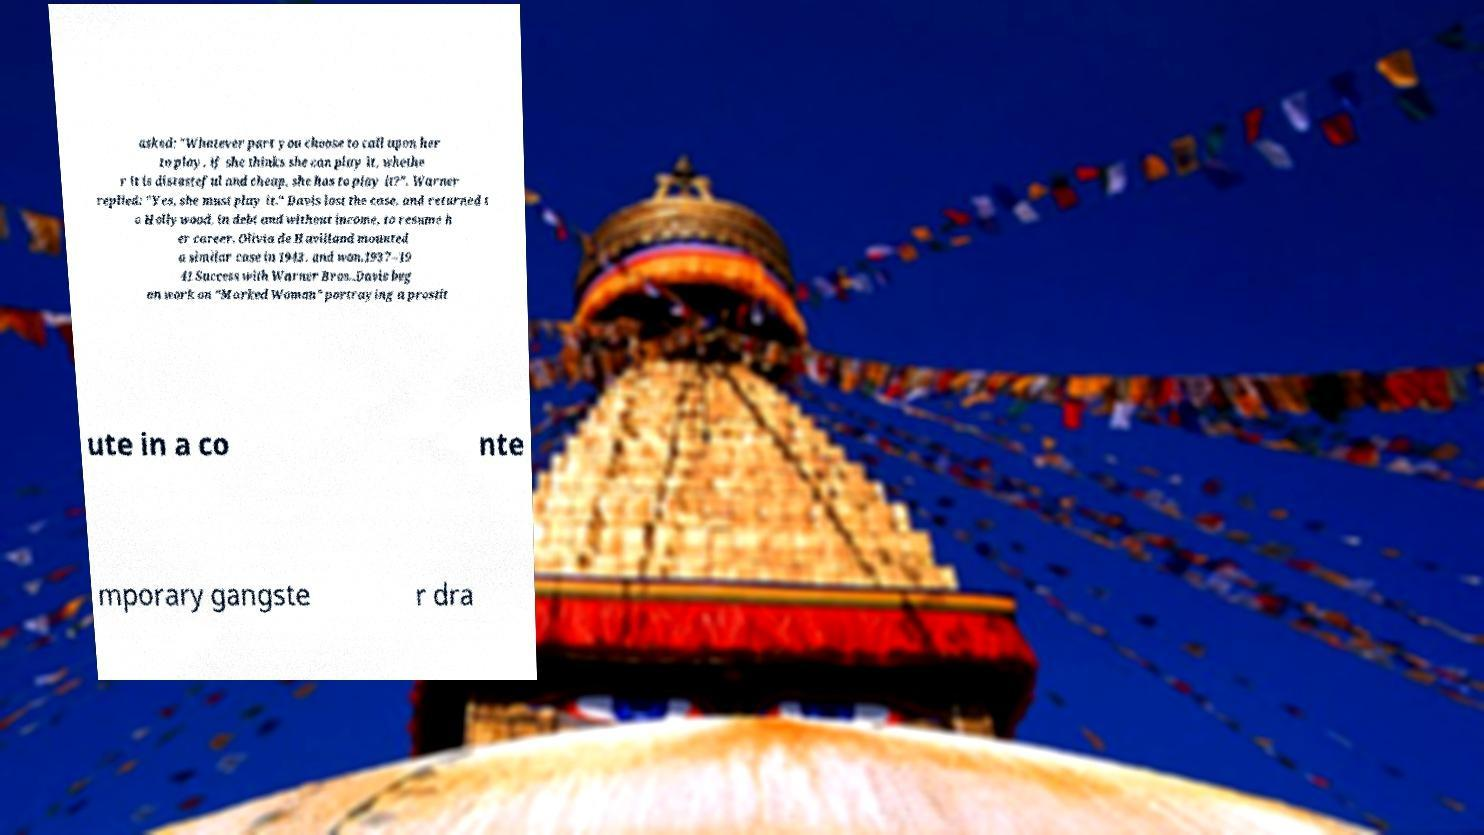Could you assist in decoding the text presented in this image and type it out clearly? asked: "Whatever part you choose to call upon her to play, if she thinks she can play it, whethe r it is distasteful and cheap, she has to play it?". Warner replied: "Yes, she must play it." Davis lost the case, and returned t o Hollywood, in debt and without income, to resume h er career. Olivia de Havilland mounted a similar case in 1943, and won.1937–19 41 Success with Warner Bros..Davis beg an work on "Marked Woman" portraying a prostit ute in a co nte mporary gangste r dra 